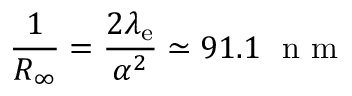Convert formula to latex. <formula><loc_0><loc_0><loc_500><loc_500>{ \frac { 1 } { R _ { \infty } } } = { \frac { 2 \lambda _ { e } } { \alpha ^ { 2 } } } \simeq 9 1 . 1 { n m }</formula> 